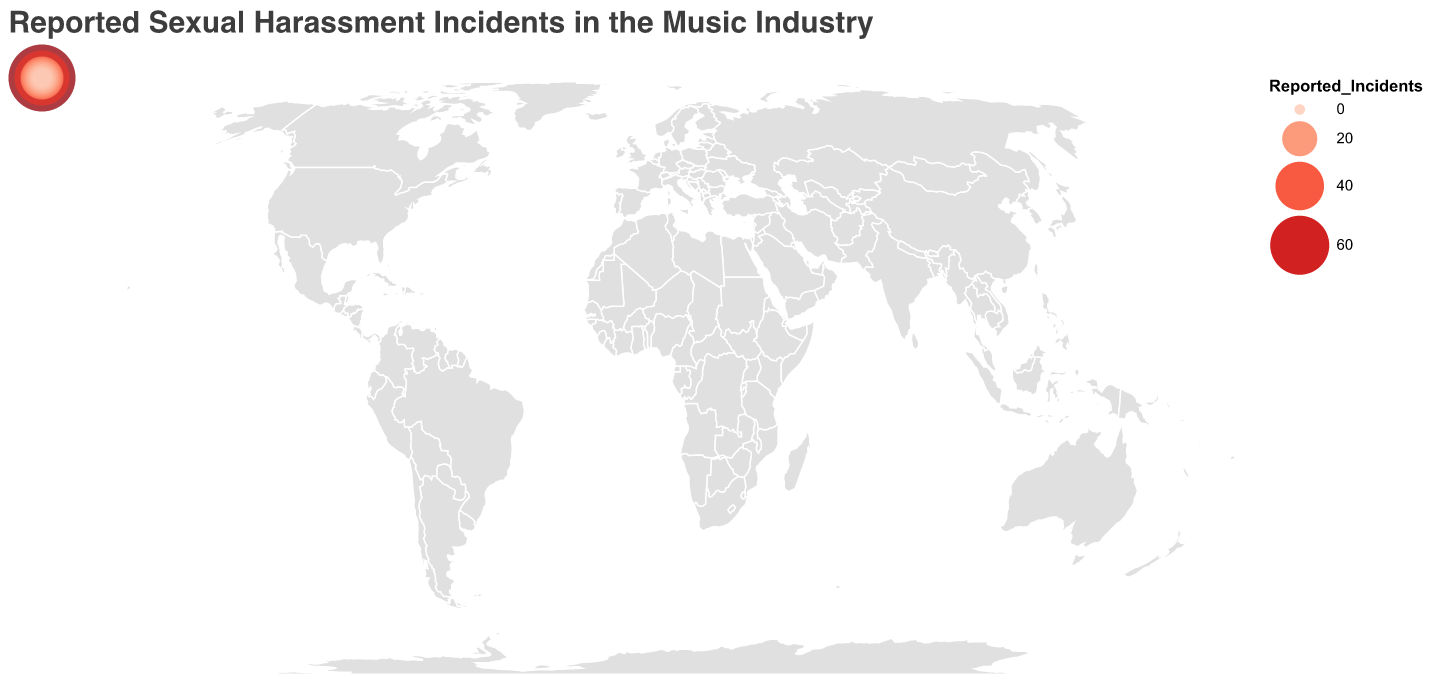How many countries are displayed in the heatmap? By counting each country listed in the data or reflected on the map, we find there are 20 countries represented.
Answer: 20 Which country has the highest number of reported incidents? The country with the highest size and darkest color circle on the map is the United States with 78 reported incidents.
Answer: United States What is the total number of reported incidents in the United States, United Kingdom, and Canada? Sum the reported incidents for the United States (78), United Kingdom (52), and Canada (31). The total is 78 + 52 + 31 = 161.
Answer: 161 Compare the reported incidents between Germany and France: Which country has a higher number, and by how much? Germany reports 25 incidents, while France reports 23. The difference is 25 - 23 = 2, with Germany having more reported incidents.
Answer: Germany, 2 Which country has fewer reported incidents: Denmark or Norway? By comparing the reported incidents, Denmark has 9 incidents and Norway has 8. Therefore, Norway has fewer incidents.
Answer: Norway What is the average number of reported incidents among all countries shown in the heatmap? Sum up the reported incidents from all 20 countries and divide by 20. The total sum is 78 + 52 + 31 + 29 + 25 + 23 + 20 + 18 + 16 + 15 + 13 + 12 + 11 + 10 + 9 + 8 + 7 + 6 + 5 + 4 = 393. The average is 393/20 = 19.65.
Answer: 19.65 Among the top five countries with the highest reported incidents, what is the median value of reported incidents? The top five countries are United States (78), United Kingdom (52), Canada (31), Australia (29), and Germany (25). To find the median, we list these in numerical order: 25, 29, 31, 52, 78. The median value is the middle number, which is 31.
Answer: 31 Draw conclusions from the circles' colors and sizes: Which continents seem to have a higher concentration of reported incidents? The larger and darker circles are concentrated in North America (United States, Canada), Europe (United Kingdom, Germany, France), and Australia, indicating a higher concentration of reported incidents in these regions.
Answer: North America, Europe, Australia What is the smallest number of reported incidents for a country listed, and which country or countries have this number? The smallest number of reported incidents shown is 4, and it corresponds to Switzerland.
Answer: 4, Switzerland 